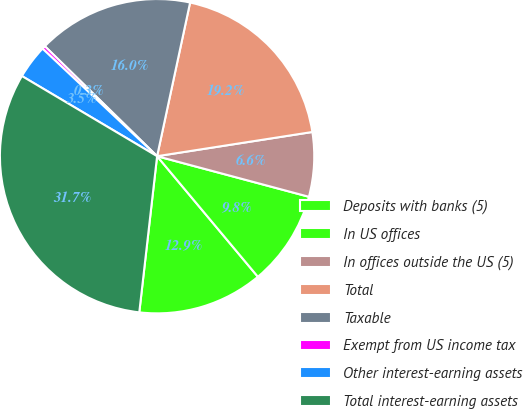Convert chart. <chart><loc_0><loc_0><loc_500><loc_500><pie_chart><fcel>Deposits with banks (5)<fcel>In US offices<fcel>In offices outside the US (5)<fcel>Total<fcel>Taxable<fcel>Exempt from US income tax<fcel>Other interest-earning assets<fcel>Total interest-earning assets<nl><fcel>12.89%<fcel>9.76%<fcel>6.62%<fcel>19.17%<fcel>16.03%<fcel>0.34%<fcel>3.48%<fcel>31.71%<nl></chart> 